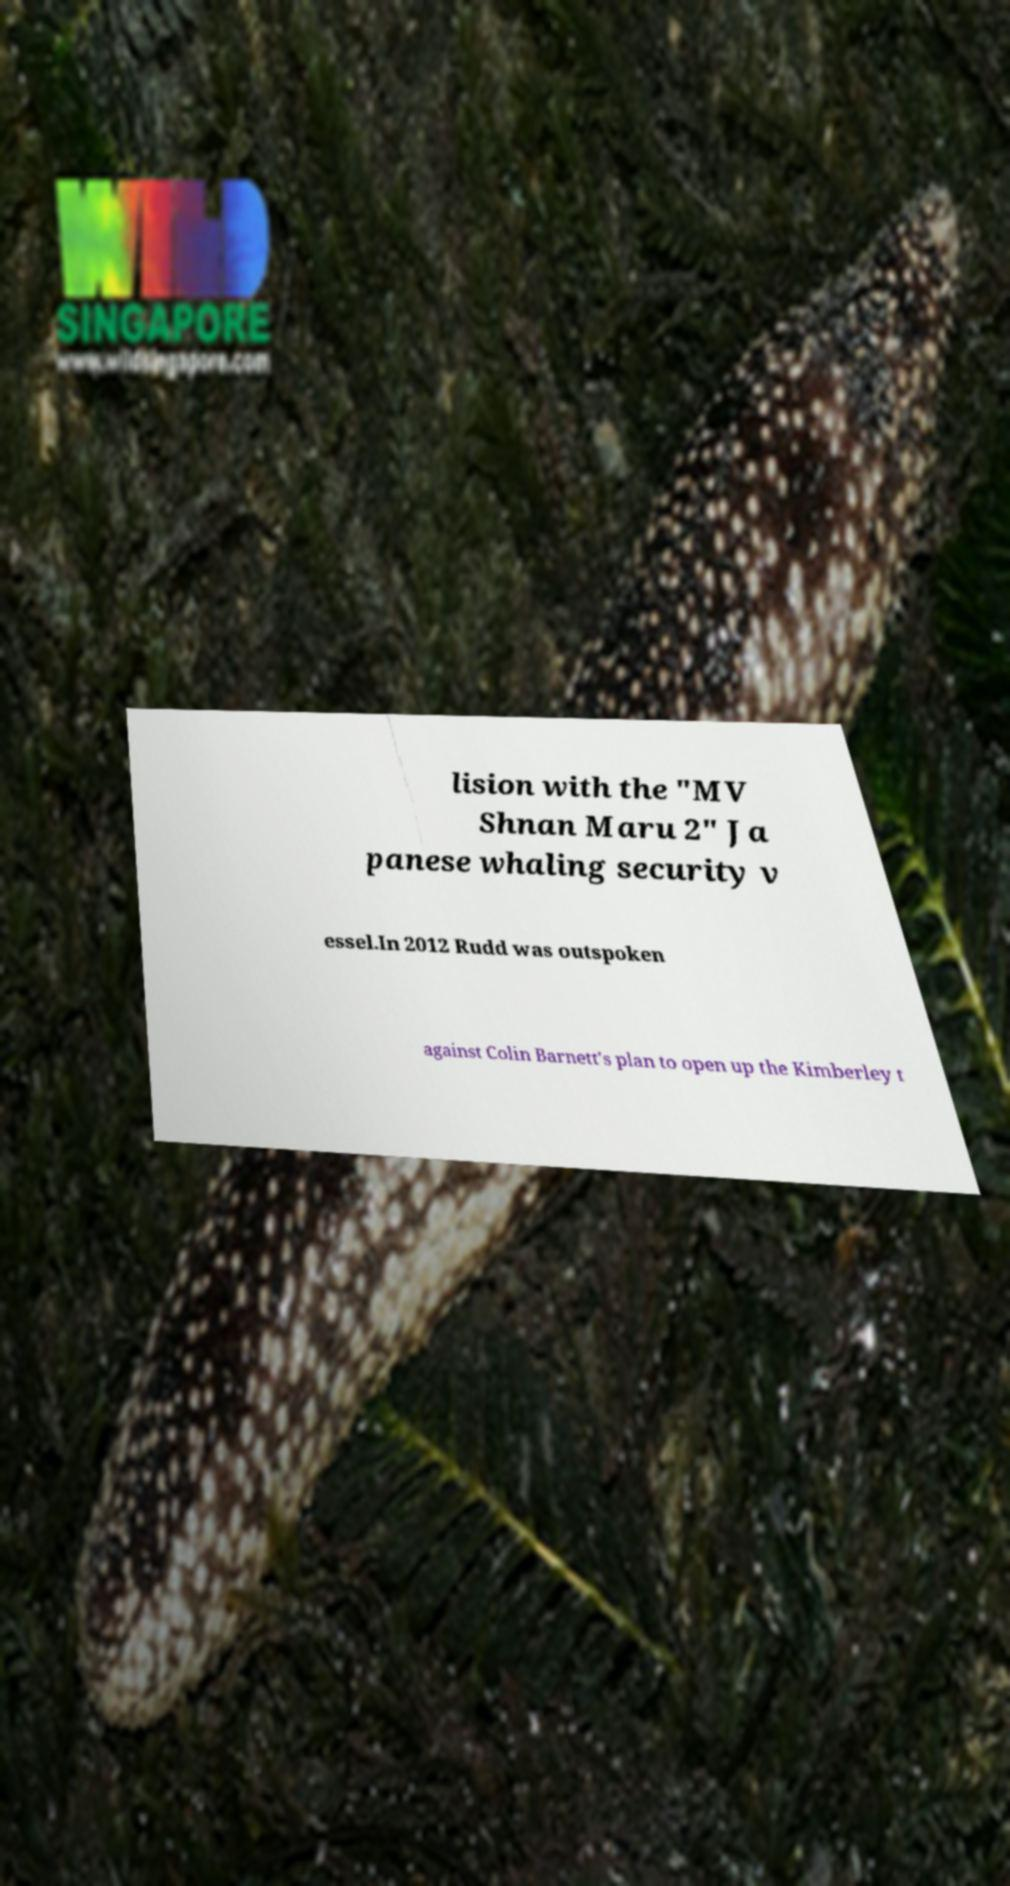For documentation purposes, I need the text within this image transcribed. Could you provide that? lision with the "MV Shnan Maru 2" Ja panese whaling security v essel.In 2012 Rudd was outspoken against Colin Barnett's plan to open up the Kimberley t 